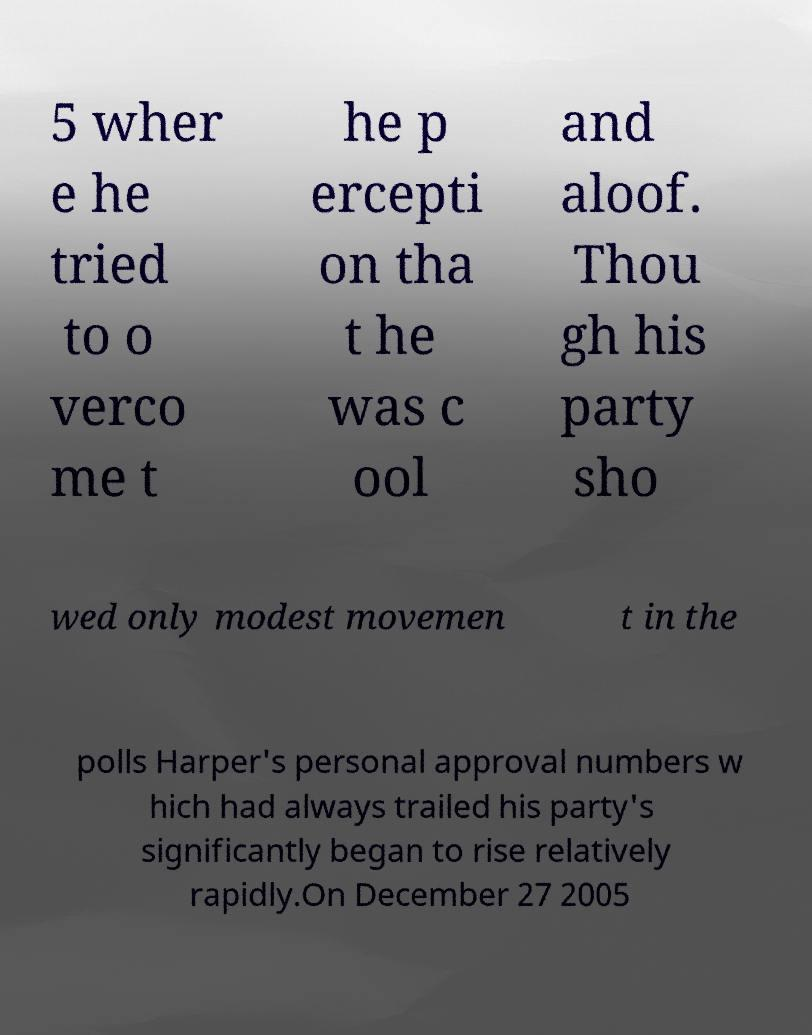Can you read and provide the text displayed in the image?This photo seems to have some interesting text. Can you extract and type it out for me? 5 wher e he tried to o verco me t he p ercepti on tha t he was c ool and aloof. Thou gh his party sho wed only modest movemen t in the polls Harper's personal approval numbers w hich had always trailed his party's significantly began to rise relatively rapidly.On December 27 2005 